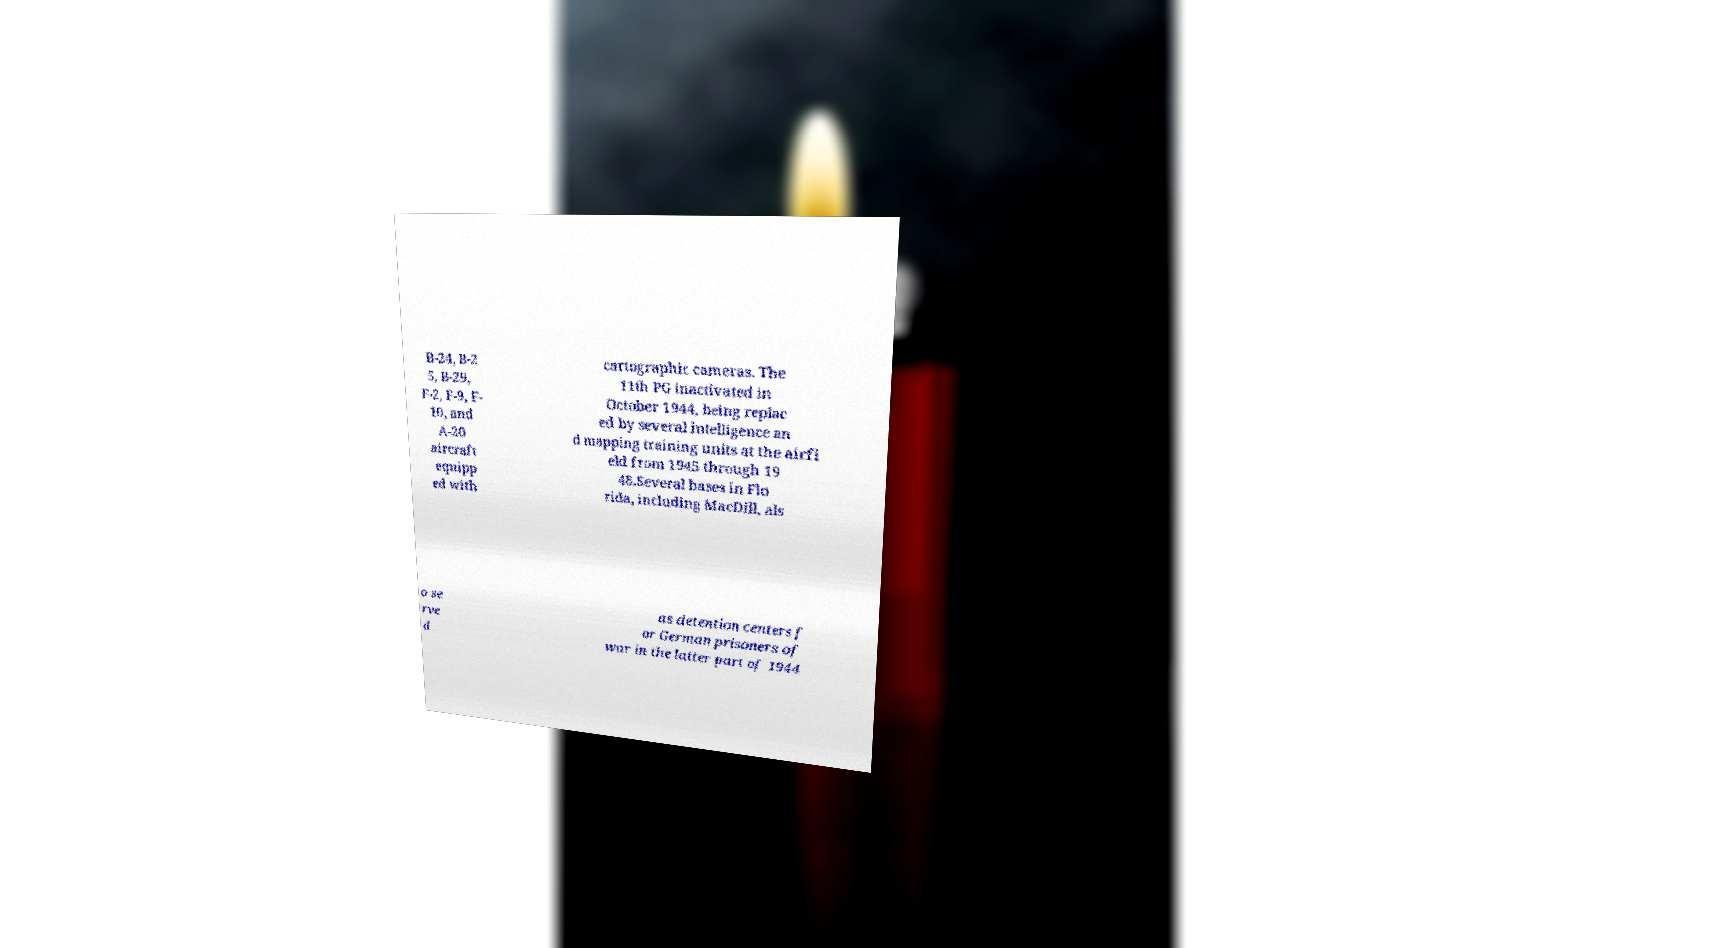What messages or text are displayed in this image? I need them in a readable, typed format. B-24, B-2 5, B-29, F-2, F-9, F- 10, and A-20 aircraft equipp ed with cartographic cameras. The 11th PG inactivated in October 1944, being replac ed by several intelligence an d mapping training units at the airfi eld from 1945 through 19 48.Several bases in Flo rida, including MacDill, als o se rve d as detention centers f or German prisoners of war in the latter part of 1944 